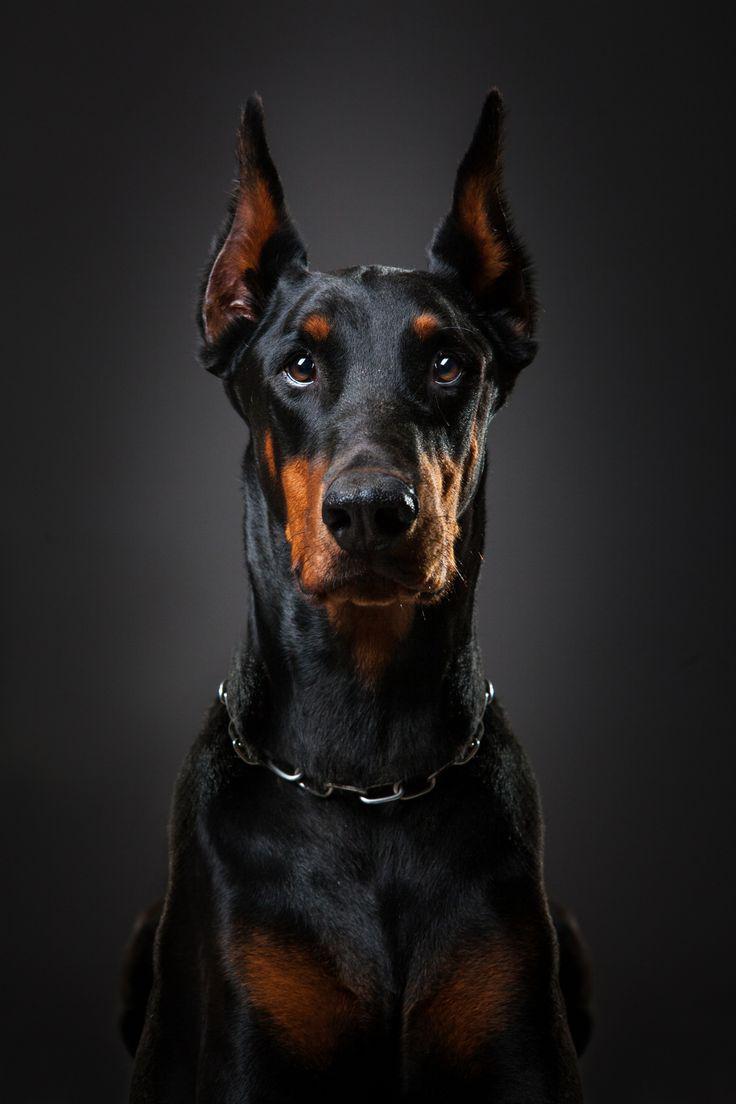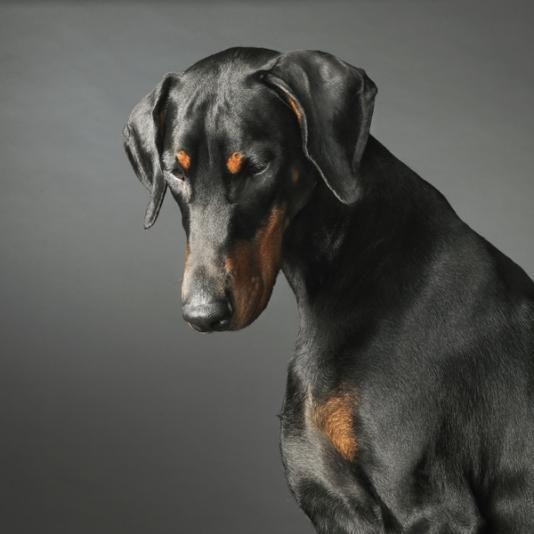The first image is the image on the left, the second image is the image on the right. For the images displayed, is the sentence "The dog in the image on the left is wearing a collar." factually correct? Answer yes or no. Yes. The first image is the image on the left, the second image is the image on the right. Given the left and right images, does the statement "The doberman on the left has upright ears and wears a collar, and the doberman on the right has floppy ears and no collar." hold true? Answer yes or no. Yes. 